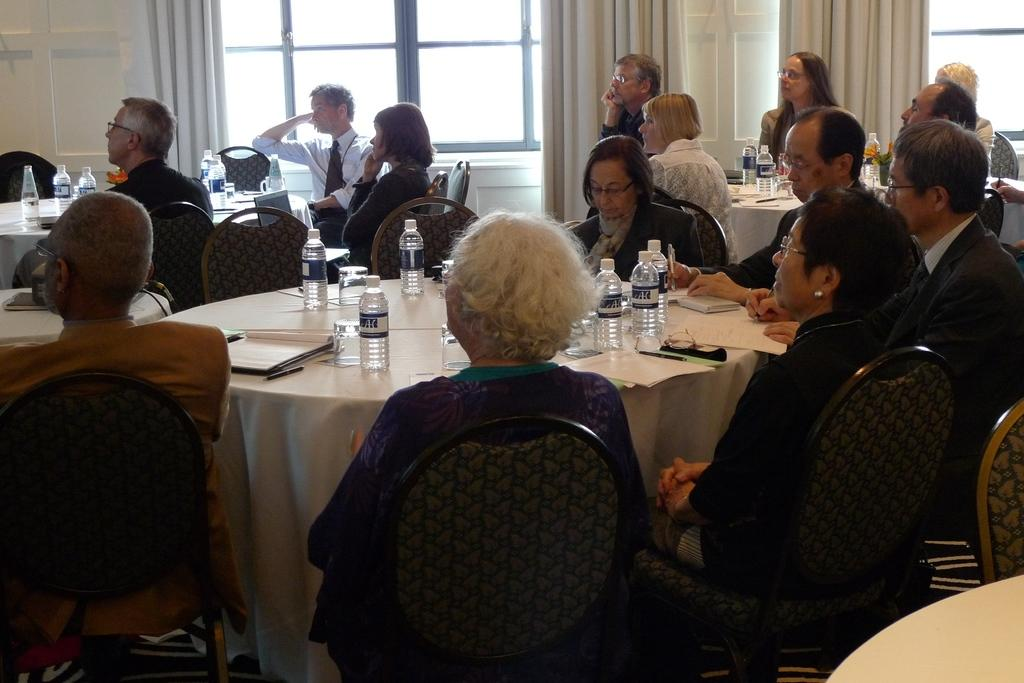What are the people in the image doing? The people in the image are sitting on chairs around a table. What objects can be seen on the table? There are bottles and books on the table. What is visible in the background of the image? There are windows in the background. What type of window treatment is present in the image? There are curtains associated with the windows. What type of line can be seen connecting the books on the table? There is no line connecting the books on the table in the image. Can you see a donkey in the image? No, there is no donkey present in the image. 